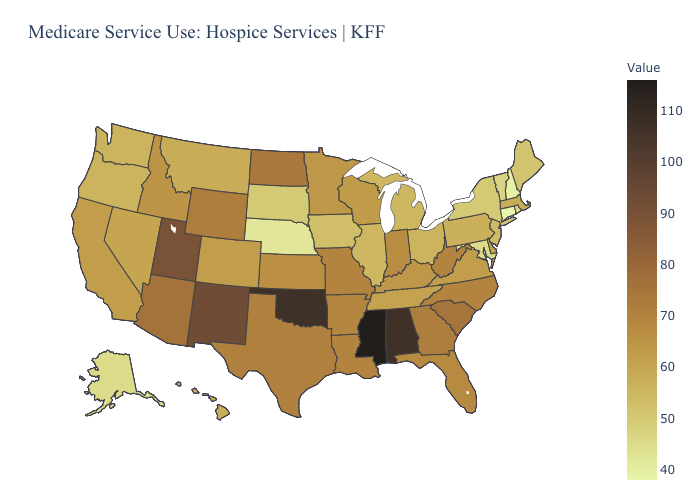Which states have the highest value in the USA?
Keep it brief. Mississippi. Which states have the lowest value in the USA?
Concise answer only. Connecticut. Does New Jersey have a lower value than Mississippi?
Be succinct. Yes. Does Texas have the highest value in the USA?
Keep it brief. No. Does Nebraska have the lowest value in the MidWest?
Concise answer only. Yes. Does Mississippi have the highest value in the USA?
Short answer required. Yes. Among the states that border Massachusetts , does Connecticut have the lowest value?
Write a very short answer. Yes. Among the states that border Montana , which have the lowest value?
Short answer required. South Dakota. 